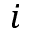<formula> <loc_0><loc_0><loc_500><loc_500>i</formula> 